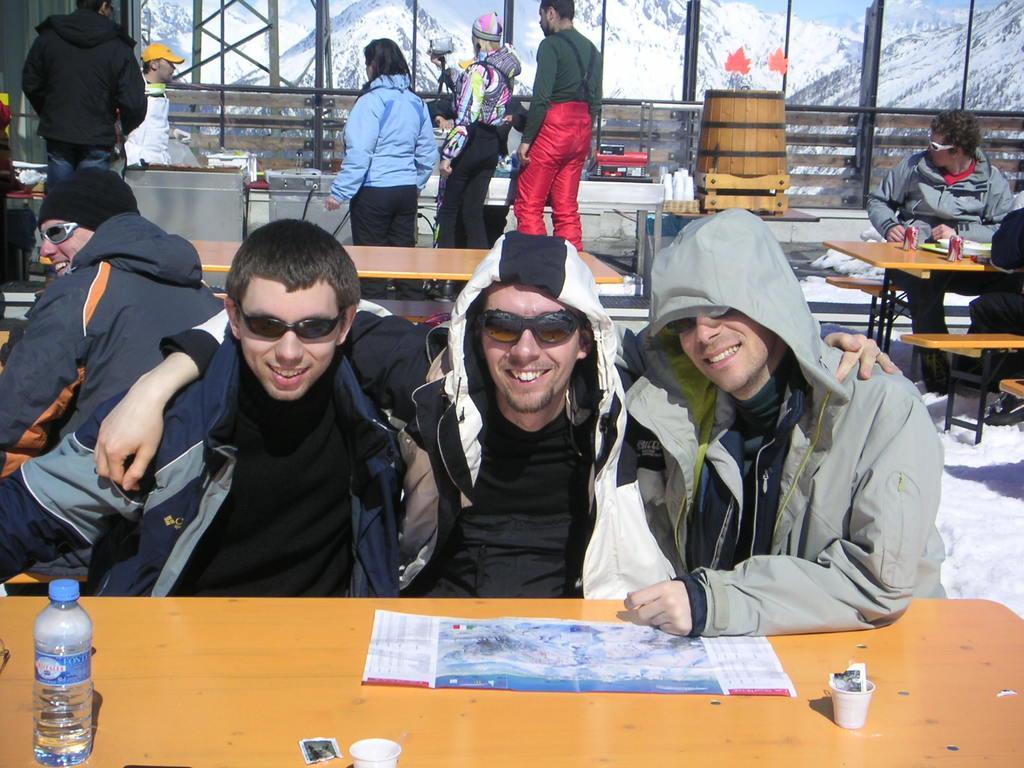Could you give a brief overview of what you see in this image? In this image there are three persons sitting and smiling, there are papers, glasses and a bottle on the table, and in the background there are group of people standing, group of people sitting , there are some objects on the tables, there are snow mountains and sky. 